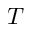Convert formula to latex. <formula><loc_0><loc_0><loc_500><loc_500>T</formula> 